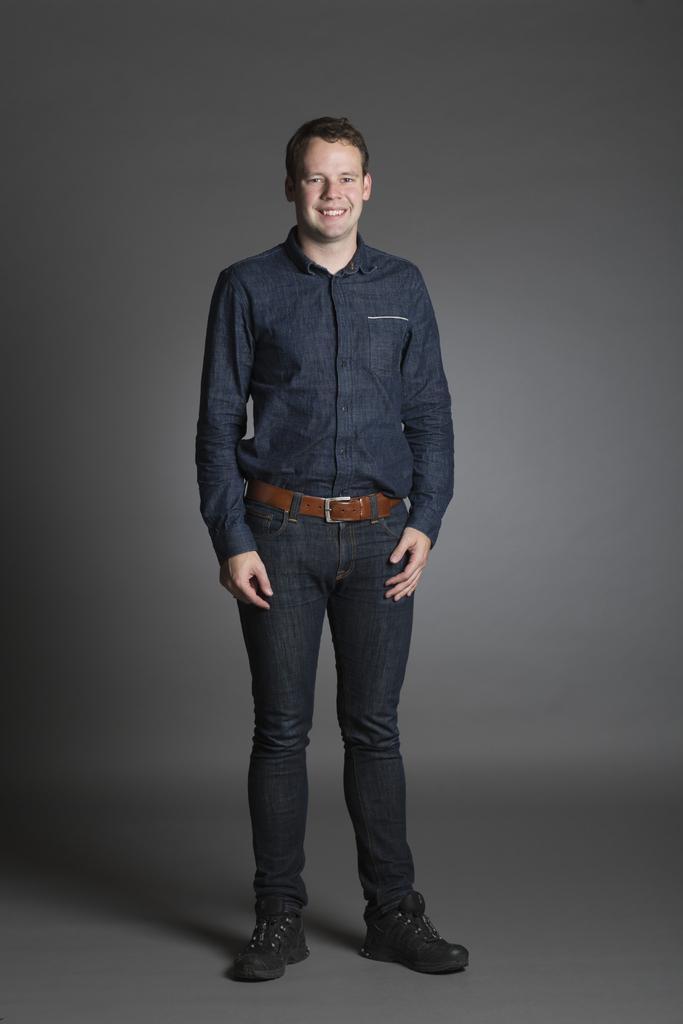In one or two sentences, can you explain what this image depicts? In this image we can see a man is standing and smiling. He is wearing shirt, brown belt, black jeans and black shoes. The background is grey in color. 